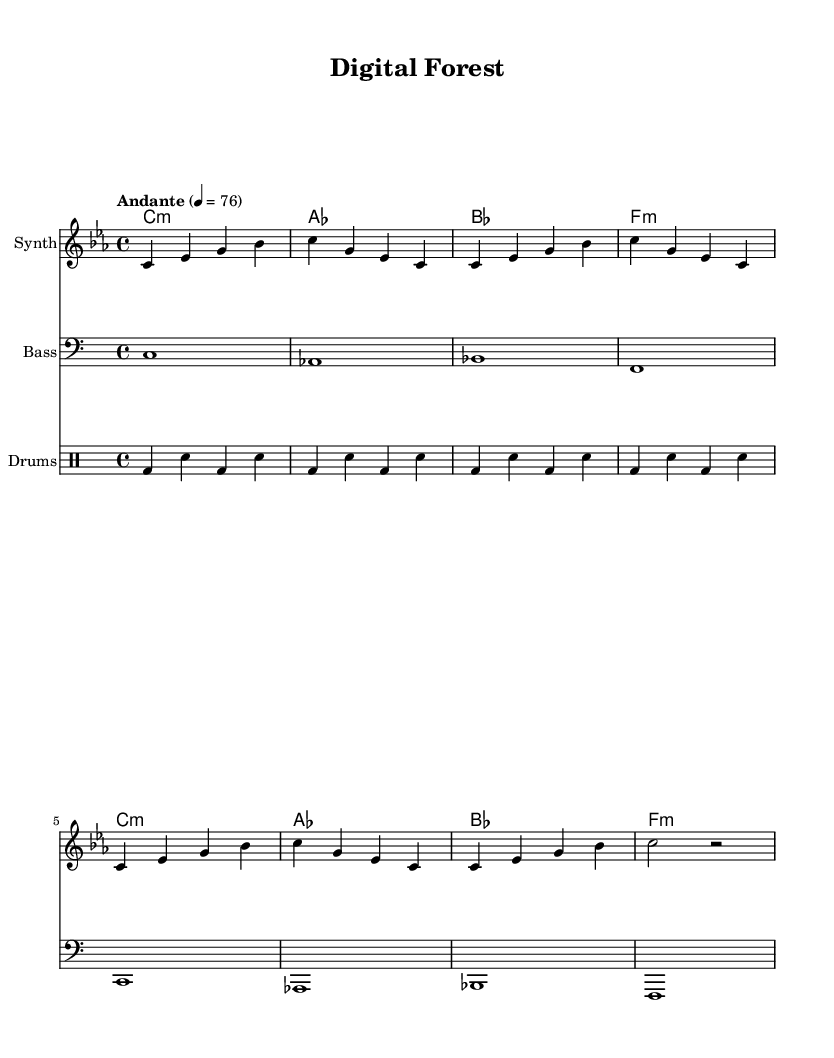What is the key signature of this music? The key signature is indicated at the beginning of the staff and is C minor, which has three flats: B♭, E♭, and A♭.
Answer: C minor What is the time signature of this music? The time signature is shown at the beginning, indicating a 4/4 time or common time, which means there are four beats in a measure and the quarter note gets one beat.
Answer: 4/4 What is the tempo marking of this piece? The tempo marking is provided above the staff and indicates "Andante," which is a moderate walking speed, along with the metronome marking of 76 beats per minute.
Answer: Andante, 76 How many measures are there in the synth melody? By counting the measures in the synth melody line, there are a total of eight measures present.
Answer: 8 Which instruments are included in the score? The score includes a synth, bass, and drums, as indicated by the instrument names on the respective staves and drum staff.
Answer: Synth, Bass, Drums What type of chords are used in the synth part? The synth chords display a mixture of minor chords, which indicates a darker or more introspective sound, typical of the experimental genre.
Answer: Minor What does the drum pattern consist of? The drum pattern primarily consists of bass drum ('bd') and snare ('sn') notes in a repeated rhythmic pattern, characteristic of experimental electronic music.
Answer: Bass and Snare 